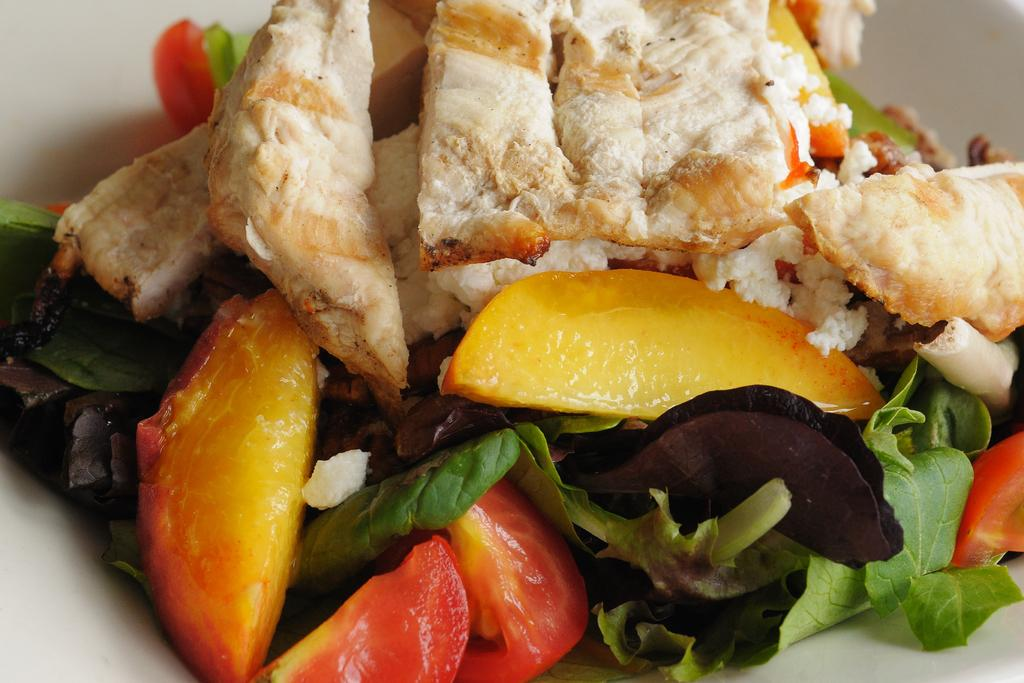What is in the middle of the image? There is a bowl in the image, which is in the middle of the image. What color is the bowl? The bowl is white in color. What is inside the bowl? There is food in the bowl. What type of street is visible in the image? There is no street present in the image; it features a bowl in the middle. Where is the tub located in the image? There is no tub present in the image. 